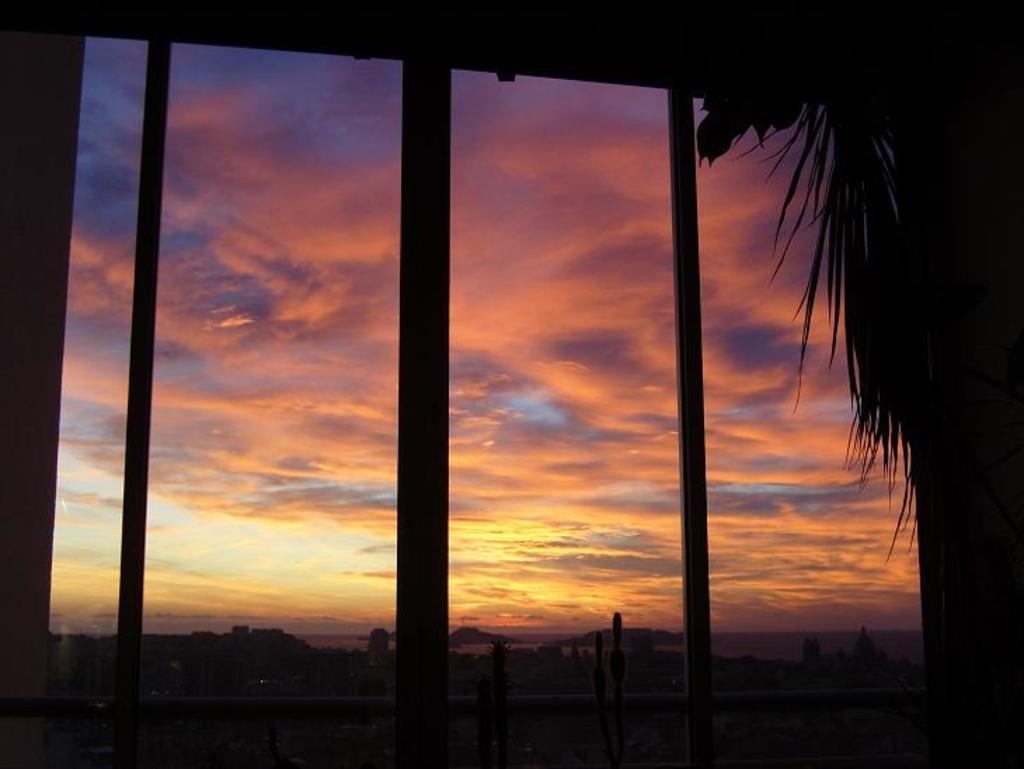Describe this image in one or two sentences. In the foreground of this image, it seems like a window and few leaves on the right. In the background, there is sky and few objects. 